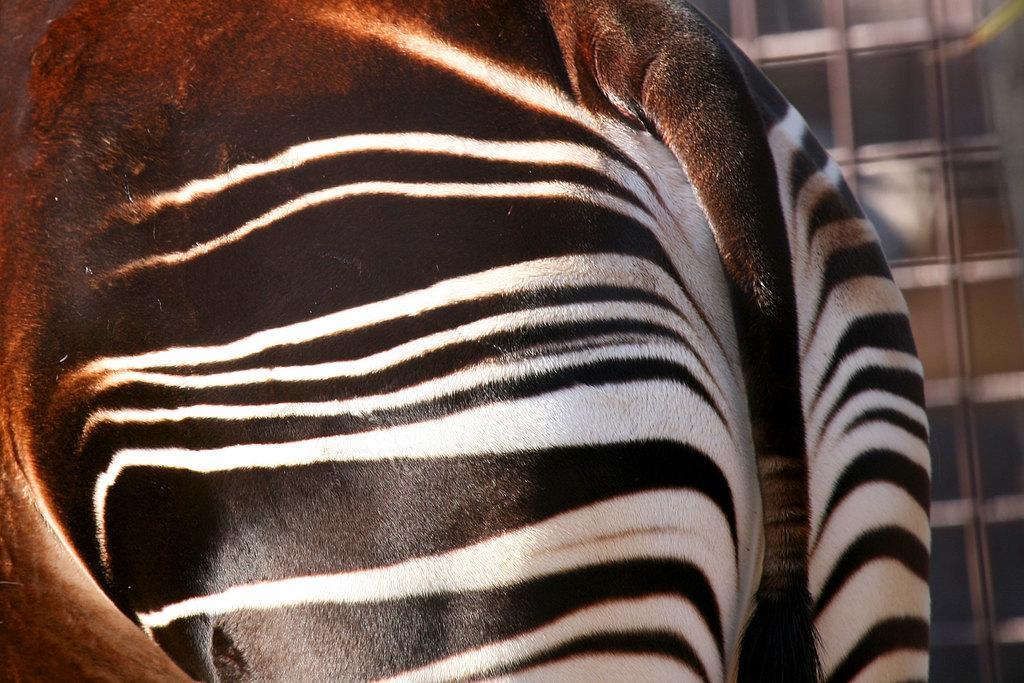Describe this image in one or two sentences. In this picture we can see an animal and in the background it is blurry. 